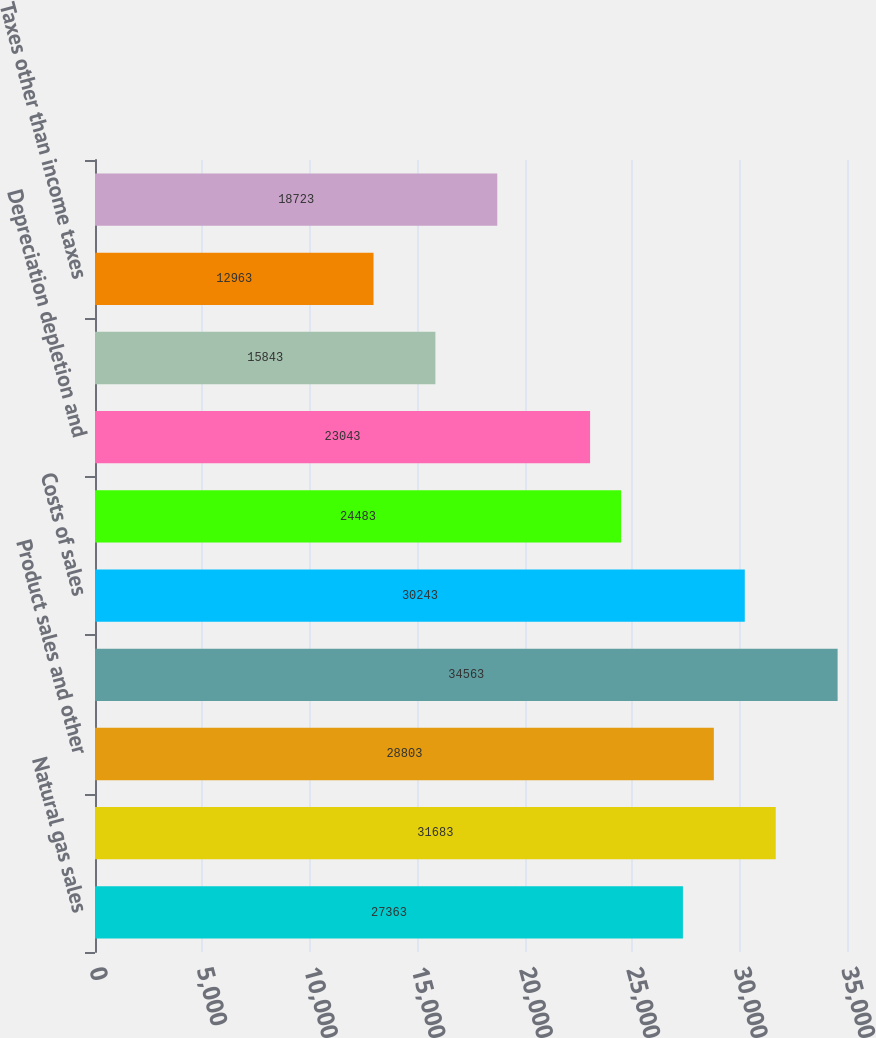Convert chart to OTSL. <chart><loc_0><loc_0><loc_500><loc_500><bar_chart><fcel>Natural gas sales<fcel>Services<fcel>Product sales and other<fcel>Total Revenues<fcel>Costs of sales<fcel>Operations and maintenance<fcel>Depreciation depletion and<fcel>General and administrative<fcel>Taxes other than income taxes<fcel>Loss (gain) on impairments and<nl><fcel>27363<fcel>31683<fcel>28803<fcel>34563<fcel>30243<fcel>24483<fcel>23043<fcel>15843<fcel>12963<fcel>18723<nl></chart> 